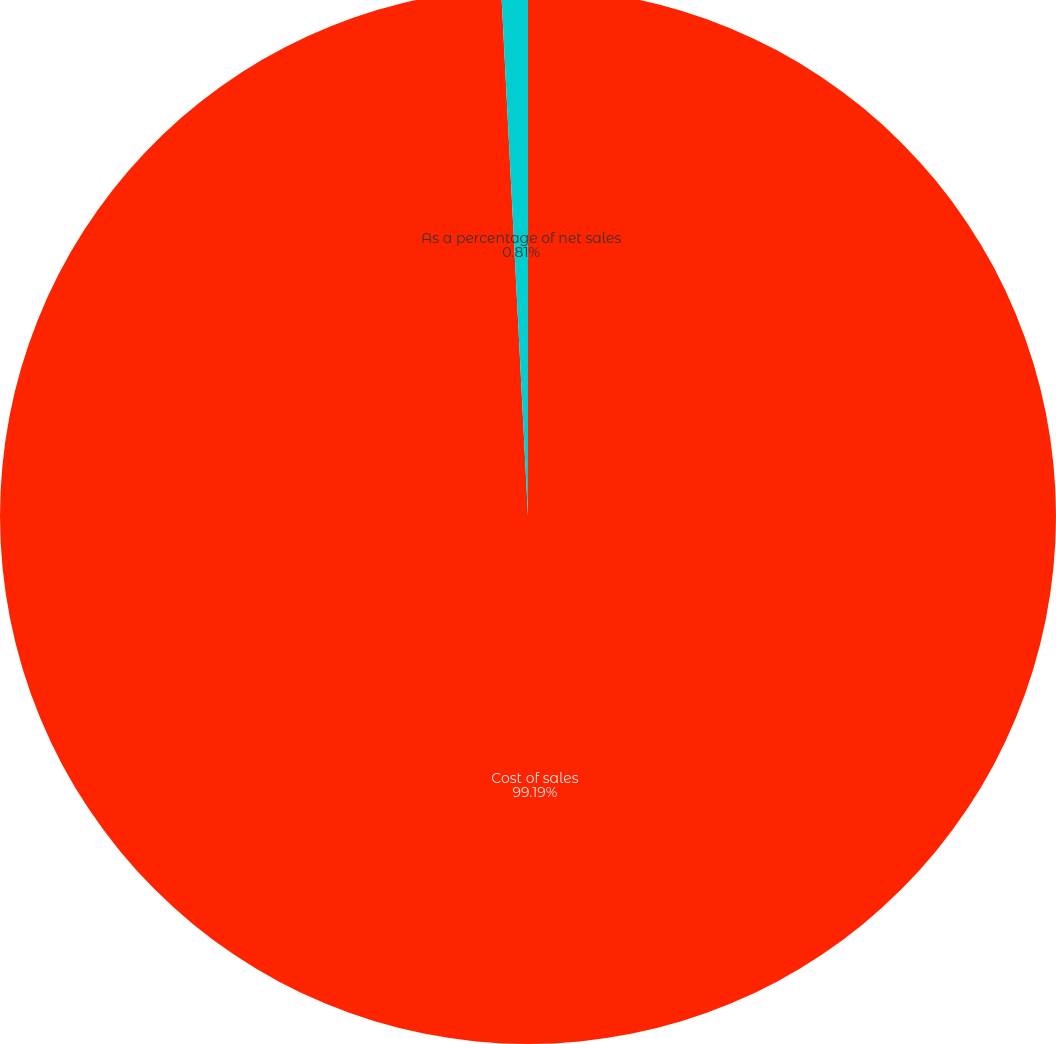Convert chart. <chart><loc_0><loc_0><loc_500><loc_500><pie_chart><fcel>Cost of sales<fcel>As a percentage of net sales<nl><fcel>99.19%<fcel>0.81%<nl></chart> 